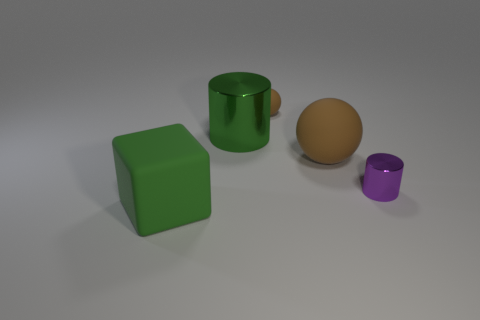Are there an equal number of brown balls in front of the purple thing and green metal cylinders?
Give a very brief answer. No. There is a cylinder that is in front of the large rubber ball; is its color the same as the big rubber object to the right of the rubber cube?
Your response must be concise. No. What material is the big object that is left of the tiny brown rubber ball and to the right of the block?
Provide a short and direct response. Metal. What is the color of the big cylinder?
Ensure brevity in your answer.  Green. How many other objects are the same shape as the small rubber thing?
Your answer should be compact. 1. Are there an equal number of small spheres left of the green metallic object and large green matte cubes that are behind the large block?
Give a very brief answer. Yes. What is the small purple object made of?
Offer a terse response. Metal. What material is the green thing to the right of the big green block?
Your response must be concise. Metal. Is there any other thing that is the same material as the big green cylinder?
Provide a succinct answer. Yes. Is the number of purple shiny objects that are in front of the green cube greater than the number of cubes?
Give a very brief answer. No. 